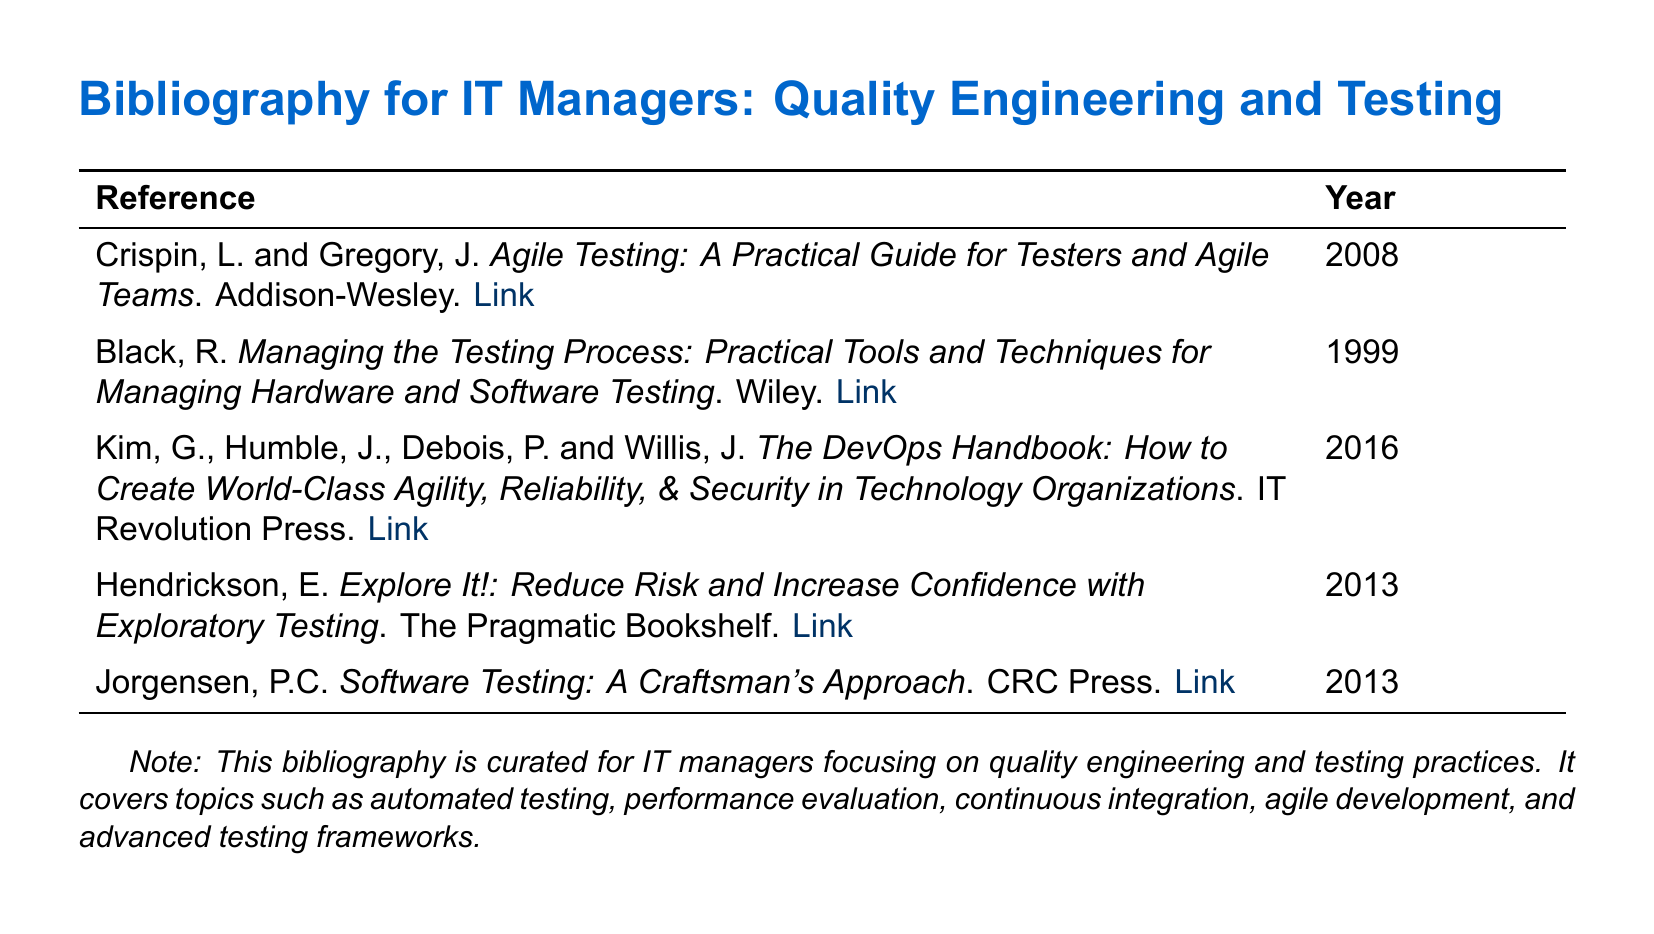What is the title of the reference by Crispin and Gregory? The title can be found in the first entry, which mentions both authors.
Answer: Agile Testing: A Practical Guide for Testers and Agile Teams What year was the book by Black published? The year can be found in the second entry of the document.
Answer: 1999 Who are the authors of "The DevOps Handbook"? The authors are listed together in the third entry of the document.
Answer: Kim, Humble, Debois, and Willis How many references are included in the bibliography? The total number of entries in the table provides this information.
Answer: Five Which publisher released "Explore It!"? The publisher is listed in the entry for the book authored by Hendrickson.
Answer: The Pragmatic Bookshelf What is the main focus of the bibliography? The focus can be inferred from the note at the bottom of the document.
Answer: Quality engineering and testing practices Which reference discusses exploratory testing? The focus of the entry indicates this aspect.
Answer: Hendrickson's book "Explore It!" What type of document is presented? The nature of this document is outlined in the title.
Answer: Bibliography 